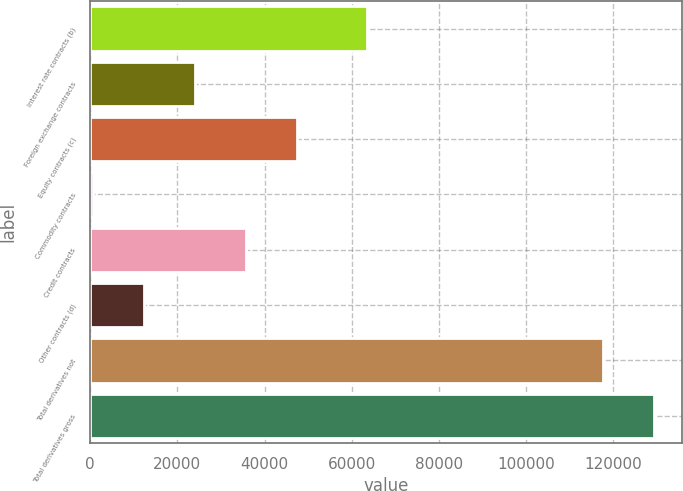<chart> <loc_0><loc_0><loc_500><loc_500><bar_chart><fcel>Interest rate contracts (b)<fcel>Foreign exchange contracts<fcel>Equity contracts (c)<fcel>Commodity contracts<fcel>Credit contracts<fcel>Other contracts (d)<fcel>Total derivatives not<fcel>Total derivatives gross<nl><fcel>63482<fcel>24023.6<fcel>47425.2<fcel>622<fcel>35724.4<fcel>12322.8<fcel>117630<fcel>129331<nl></chart> 